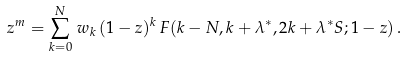<formula> <loc_0><loc_0><loc_500><loc_500>z ^ { m } = \sum _ { k = 0 } ^ { N } \, w _ { k } \, ( 1 - z ) ^ { k } \, F ( k - N , k + \lambda ^ { * } , 2 k + \lambda ^ { * } S ; 1 - z ) \, .</formula> 